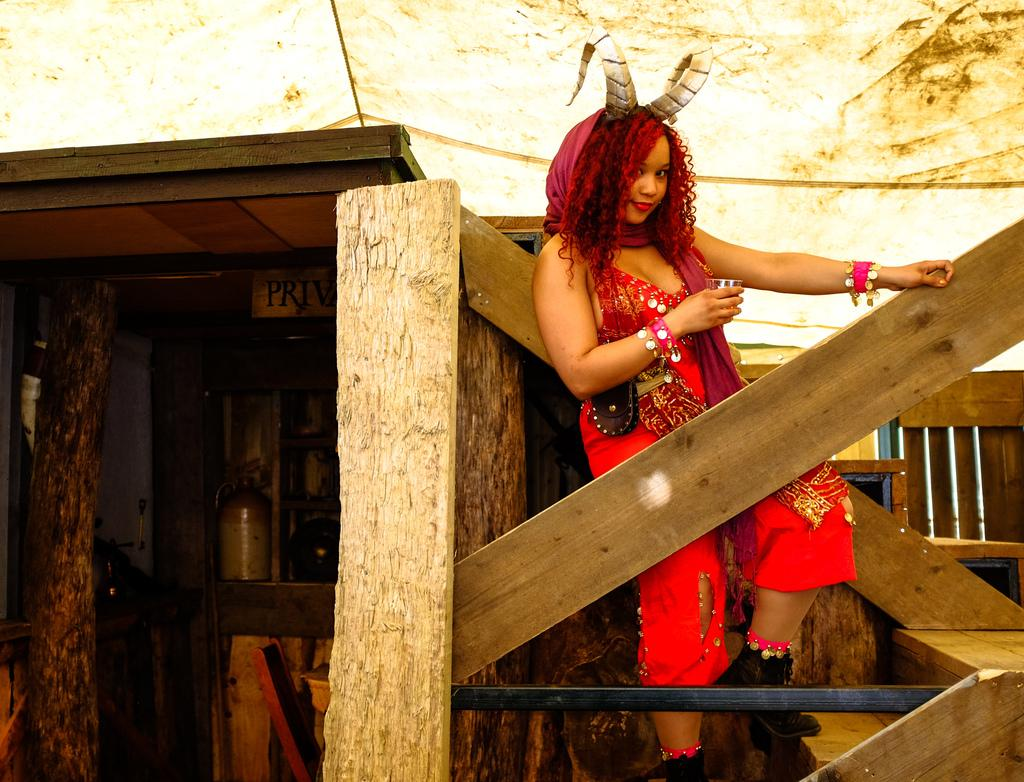Who is present in the image? There is a girl in the image. What is the girl wearing? The girl is wearing a red dress. Where is the girl standing? The girl is standing on stairs. What type of fencing is visible in the image? There is wooden fencing in the image. What piece of furniture can be seen in the image? There is a table in the image. What is on top of the table? There is a board on the table. What type of spade is the girl using to dig in the image? There is no spade present in the image, and the girl is not digging. What direction is the train traveling in the image? There is no train present in the image. 